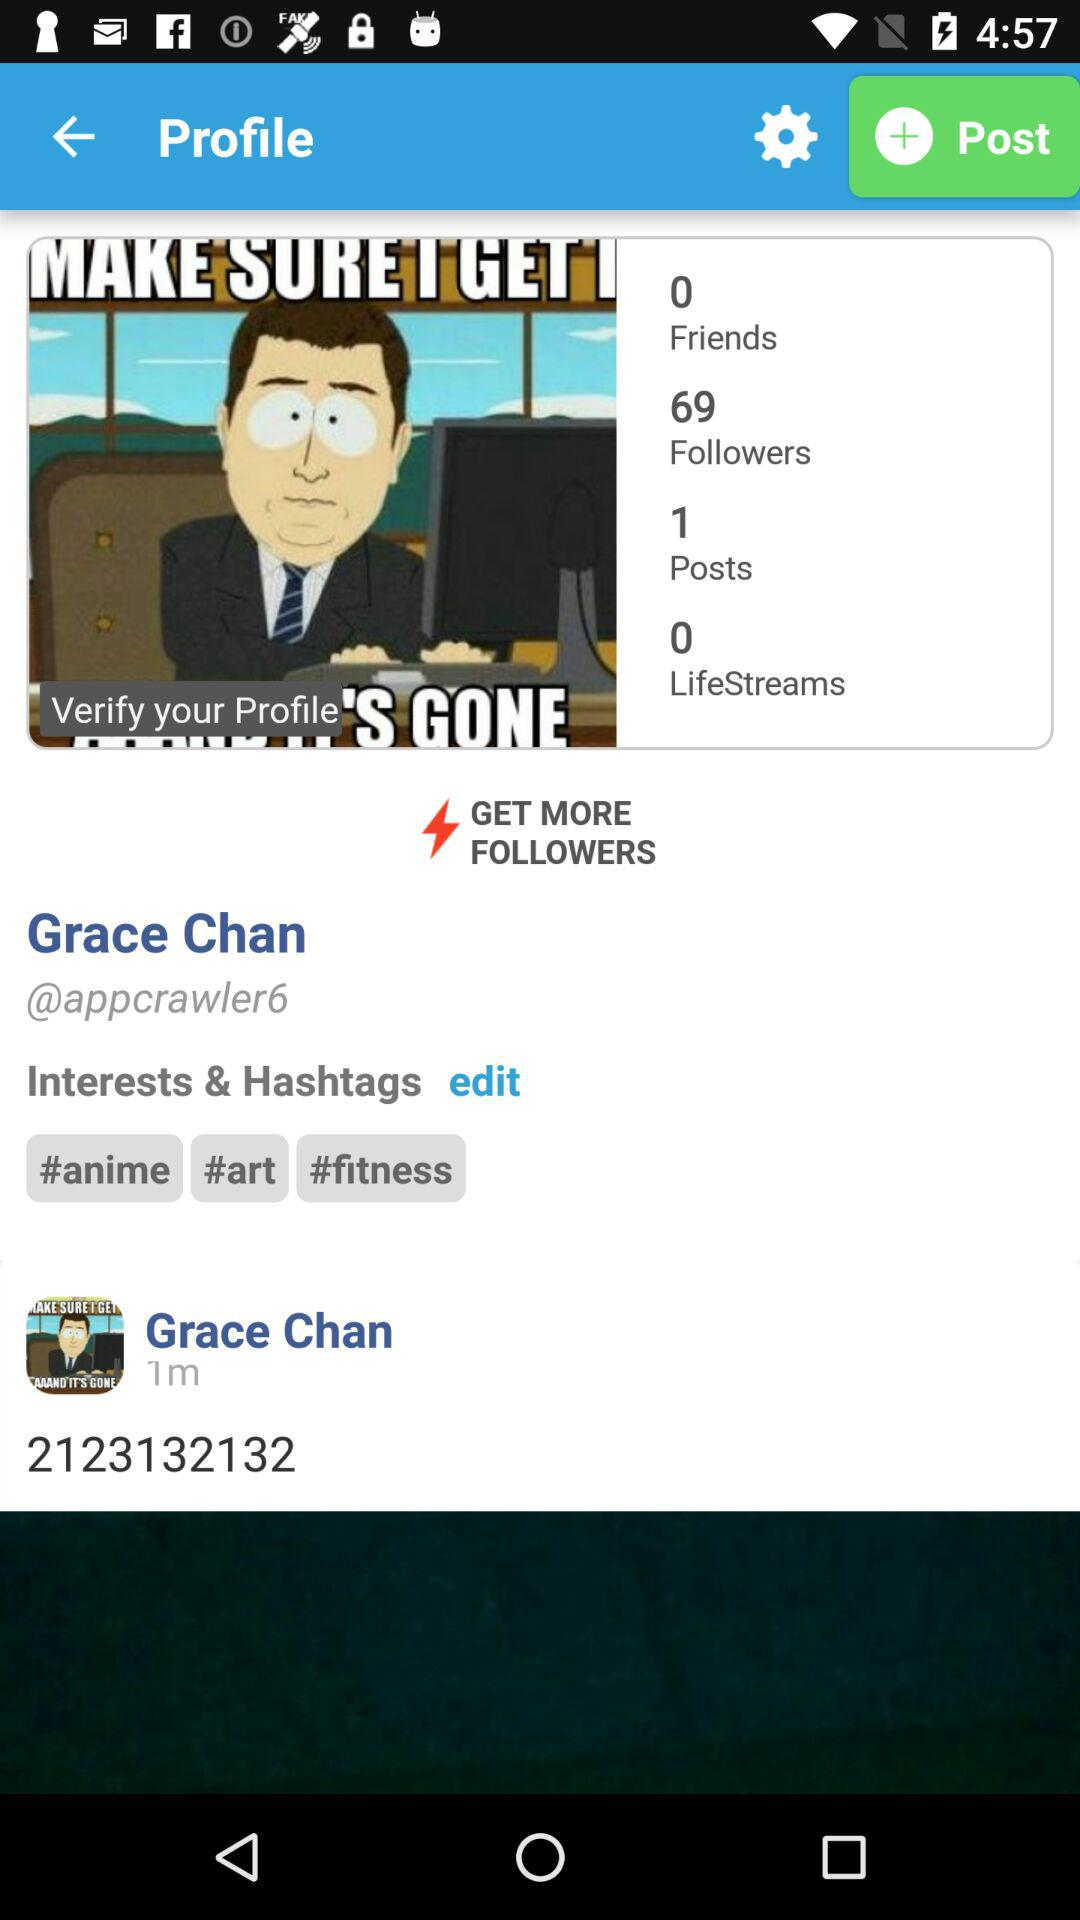How many friends does Grace Chan have? Grace Chan has 0 friends. 